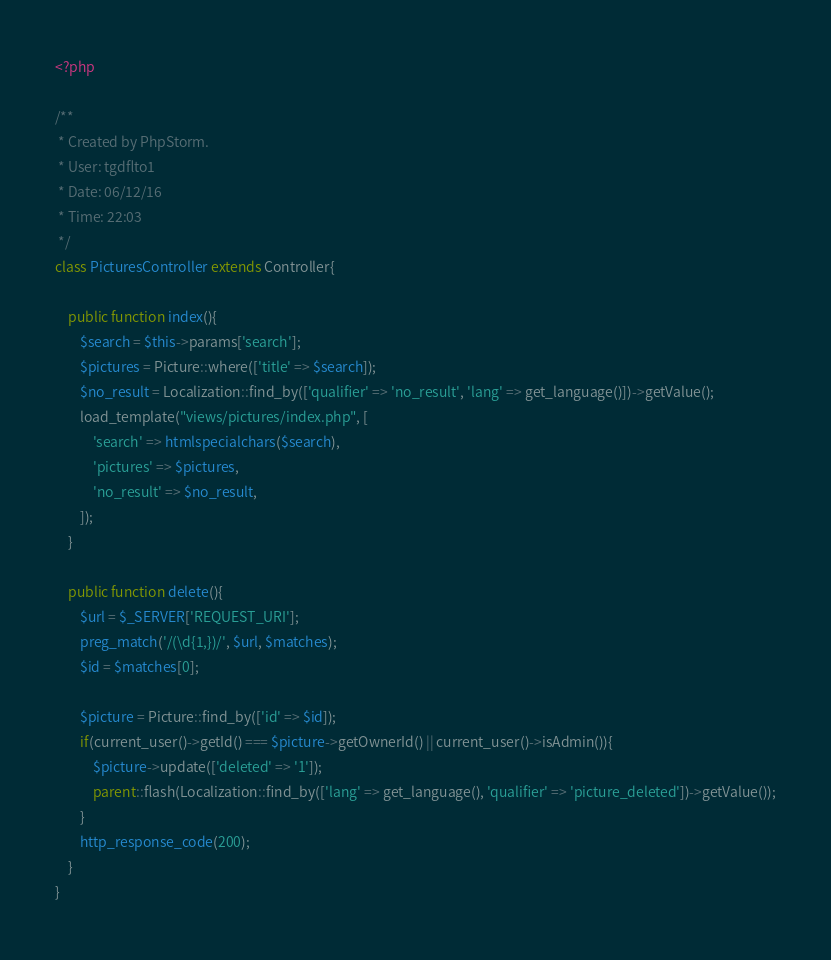Convert code to text. <code><loc_0><loc_0><loc_500><loc_500><_PHP_><?php

/**
 * Created by PhpStorm.
 * User: tgdflto1
 * Date: 06/12/16
 * Time: 22:03
 */
class PicturesController extends Controller{

	public function index(){
		$search = $this->params['search'];
		$pictures = Picture::where(['title' => $search]);
		$no_result = Localization::find_by(['qualifier' => 'no_result', 'lang' => get_language()])->getValue();
		load_template("views/pictures/index.php", [
			'search' => htmlspecialchars($search),
			'pictures' => $pictures,
			'no_result' => $no_result,
		]);
	}

	public function delete(){
		$url = $_SERVER['REQUEST_URI'];
		preg_match('/(\d{1,})/', $url, $matches);
		$id = $matches[0];

		$picture = Picture::find_by(['id' => $id]);
		if(current_user()->getId() === $picture->getOwnerId() || current_user()->isAdmin()){
			$picture->update(['deleted' => '1']);
			parent::flash(Localization::find_by(['lang' => get_language(), 'qualifier' => 'picture_deleted'])->getValue());
		}
		http_response_code(200);
	}
}</code> 